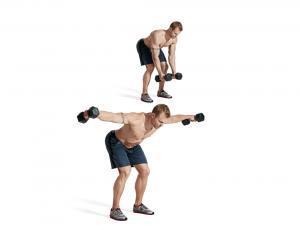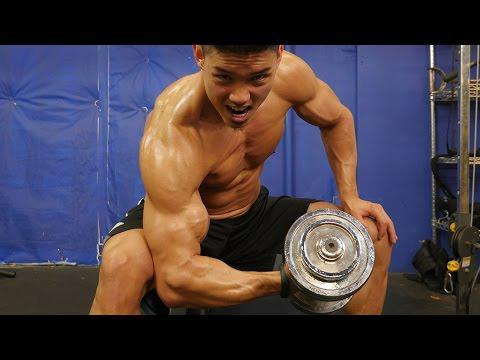The first image is the image on the left, the second image is the image on the right. Evaluate the accuracy of this statement regarding the images: "There are exactly three people working out in both images.". Is it true? Answer yes or no. Yes. The first image is the image on the left, the second image is the image on the right. Assess this claim about the two images: "There are shirtless men lifting weights". Correct or not? Answer yes or no. Yes. 